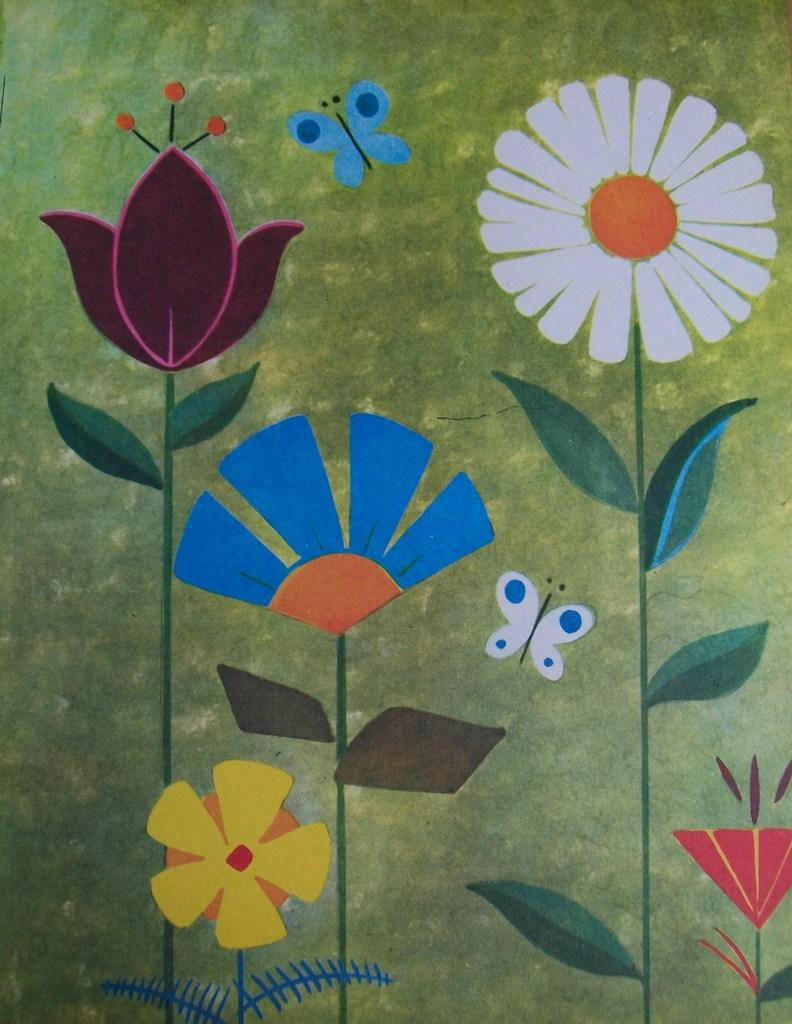What is depicted on the poster in the image? There is a poster with a painting in the image. What type of plants can be seen in the image? There are plants with flowers in the image. What insect is present in the image? There is a butterfly in the image. What is the color of the butterfly's background? The background color of the butterfly is green. What type of milk is being poured on the plants in the image? There is no milk being poured on the plants in the image; the plants have flowers. What role does the cast play in the image? There is no cast present in the image; it features a poster, plants, and a butterfly. 